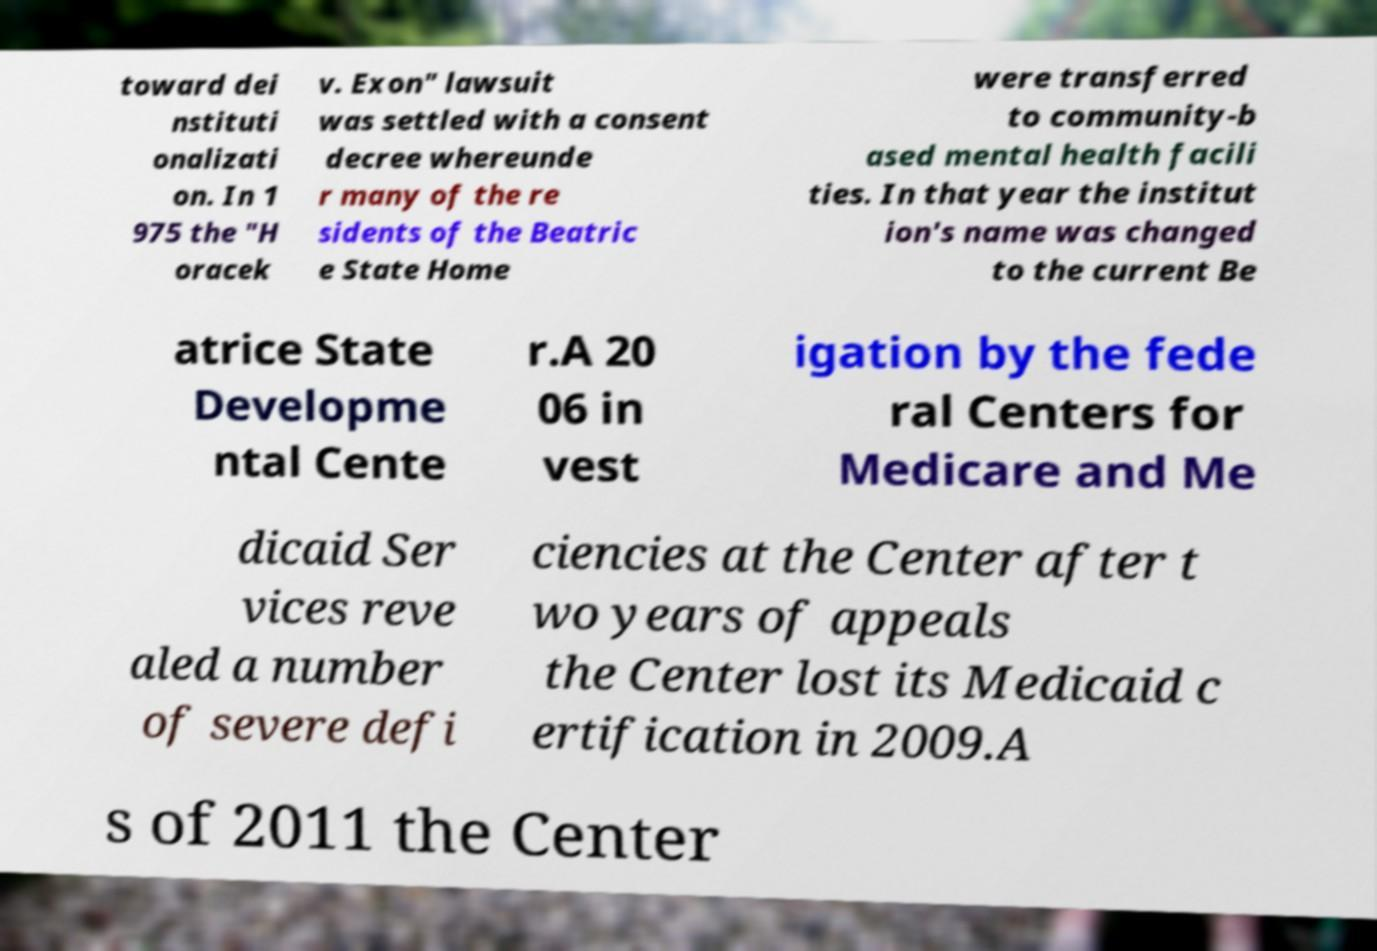Could you assist in decoding the text presented in this image and type it out clearly? toward dei nstituti onalizati on. In 1 975 the "H oracek v. Exon" lawsuit was settled with a consent decree whereunde r many of the re sidents of the Beatric e State Home were transferred to community-b ased mental health facili ties. In that year the institut ion's name was changed to the current Be atrice State Developme ntal Cente r.A 20 06 in vest igation by the fede ral Centers for Medicare and Me dicaid Ser vices reve aled a number of severe defi ciencies at the Center after t wo years of appeals the Center lost its Medicaid c ertification in 2009.A s of 2011 the Center 